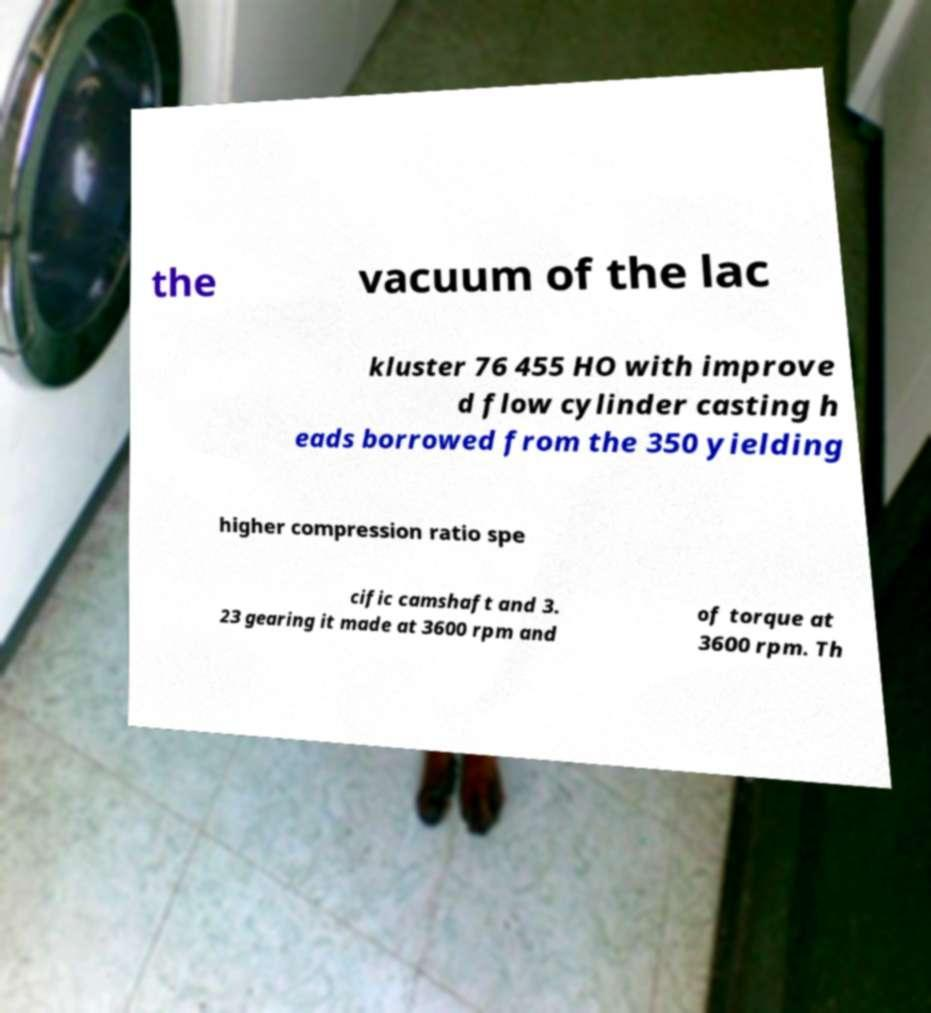Could you assist in decoding the text presented in this image and type it out clearly? the vacuum of the lac kluster 76 455 HO with improve d flow cylinder casting h eads borrowed from the 350 yielding higher compression ratio spe cific camshaft and 3. 23 gearing it made at 3600 rpm and of torque at 3600 rpm. Th 